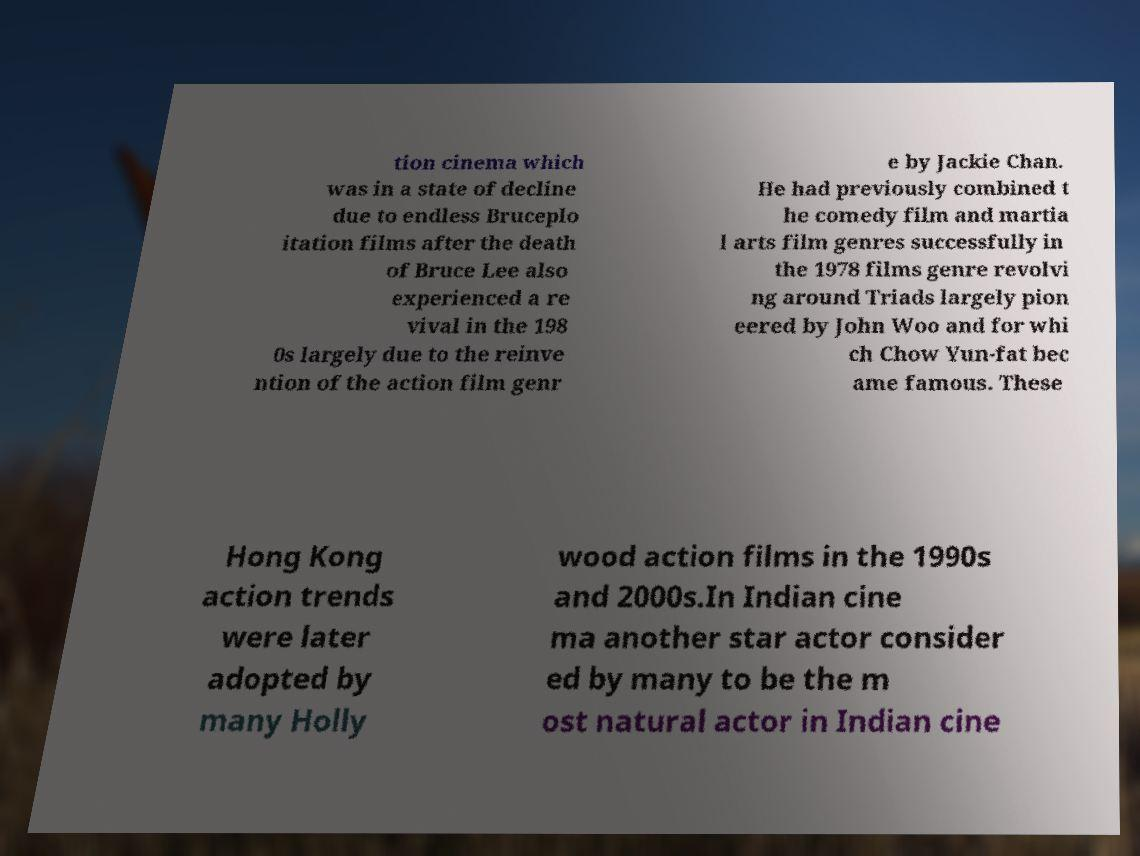Could you extract and type out the text from this image? tion cinema which was in a state of decline due to endless Bruceplo itation films after the death of Bruce Lee also experienced a re vival in the 198 0s largely due to the reinve ntion of the action film genr e by Jackie Chan. He had previously combined t he comedy film and martia l arts film genres successfully in the 1978 films genre revolvi ng around Triads largely pion eered by John Woo and for whi ch Chow Yun-fat bec ame famous. These Hong Kong action trends were later adopted by many Holly wood action films in the 1990s and 2000s.In Indian cine ma another star actor consider ed by many to be the m ost natural actor in Indian cine 